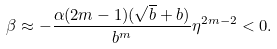<formula> <loc_0><loc_0><loc_500><loc_500>\beta \approx - \frac { \alpha ( 2 m - 1 ) ( \sqrt { b } + b ) } { b ^ { m } } \eta ^ { 2 m - 2 } < 0 .</formula> 